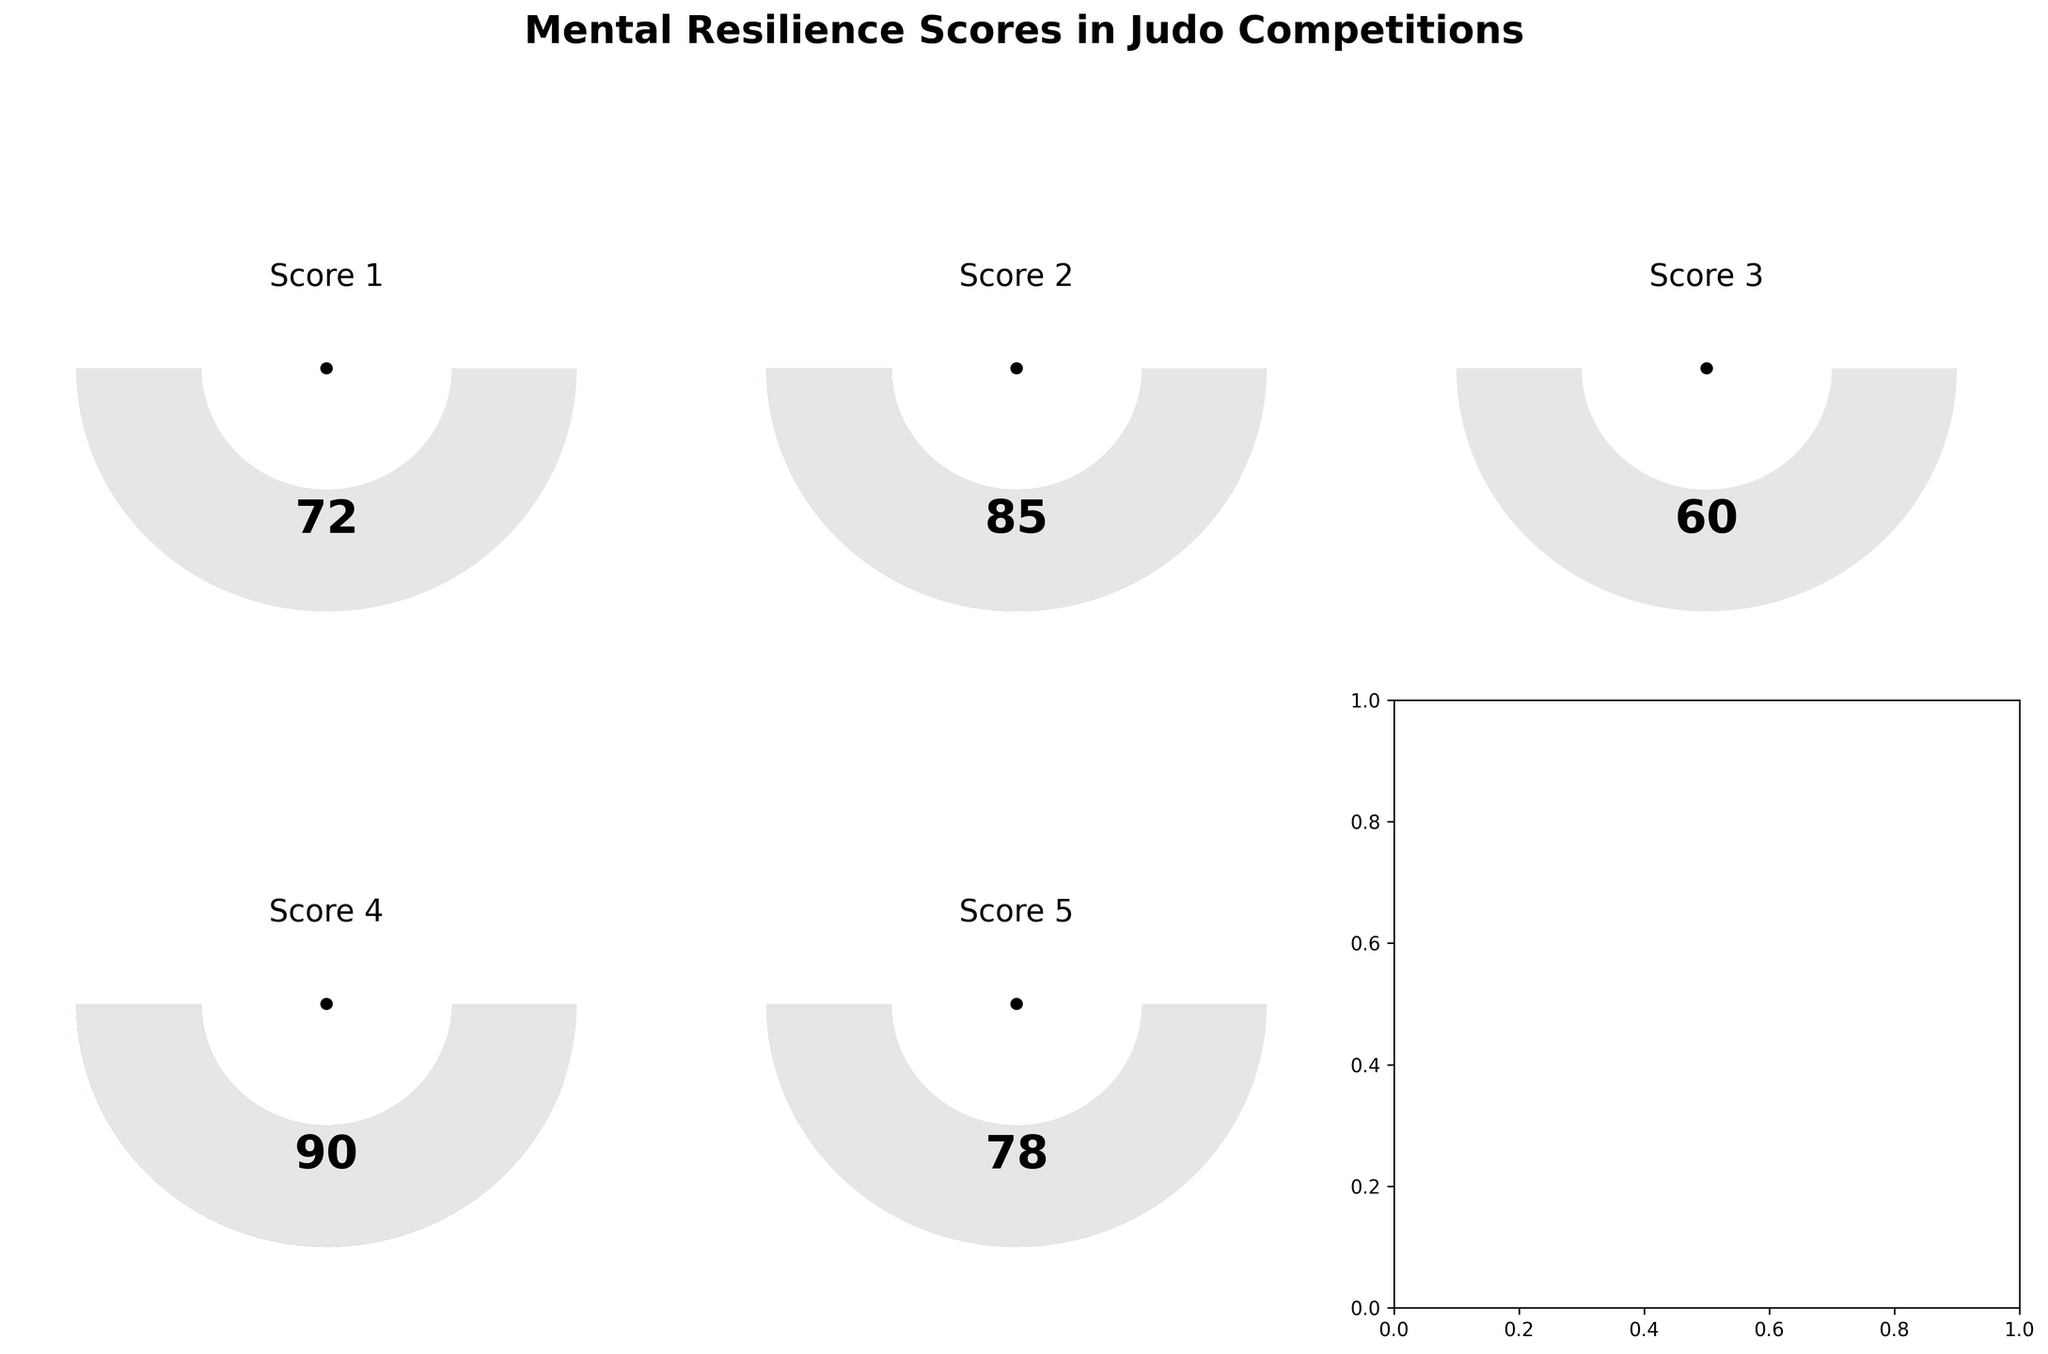What is the title of the figure? The title is at the top of the figure in large, bold font. It reads "Mental Resilience Scores in Judo Competitions".
Answer: Mental Resilience Scores in Judo Competitions How many gauge charts are shown in the figure? There are six subplots in the figure, but one of them is empty. Each of the five others contains a gauge chart.
Answer: 5 What is the value of the second mental resilience score shown? The second gauge chart has a value displayed in the center of the gauge, which is 85.
Answer: 85 Which score is the lowest? By comparing the values at the center of each gauge chart, the lowest score is 60.
Answer: 60 Is there a score that is equal to 90? The fourth gauge chart shows a value of 90 in its center.
Answer: Yes What is the average mental resilience score shown in the figure? Add all the scores [72, 85, 60, 90, 78] and divide by the number of scores (5). (72 + 85 + 60 + 90 + 78) / 5 = 385 / 5 = 77
Answer: 77 What is the median value of the scores? To find the median, arrange the scores in ascending order: [60, 72, 78, 85, 90]. The middle value in this ordered list is 78.
Answer: 78 Which gauge chart shows the highest score, and what is that score? Compare all the gauge charts and identify that the fourth chart shows the highest score which is 90.
Answer: Fourth gauge chart, 90 Which score has the widest gauge angle coverage? The gauge angles are proportional to their scores. The fourth gauge chart with a score of 90 has the widest angle coverage.
Answer: 90 Are any of the scores below 70? Only one score from the gauge charts is below 70, which is 60.
Answer: Yes 